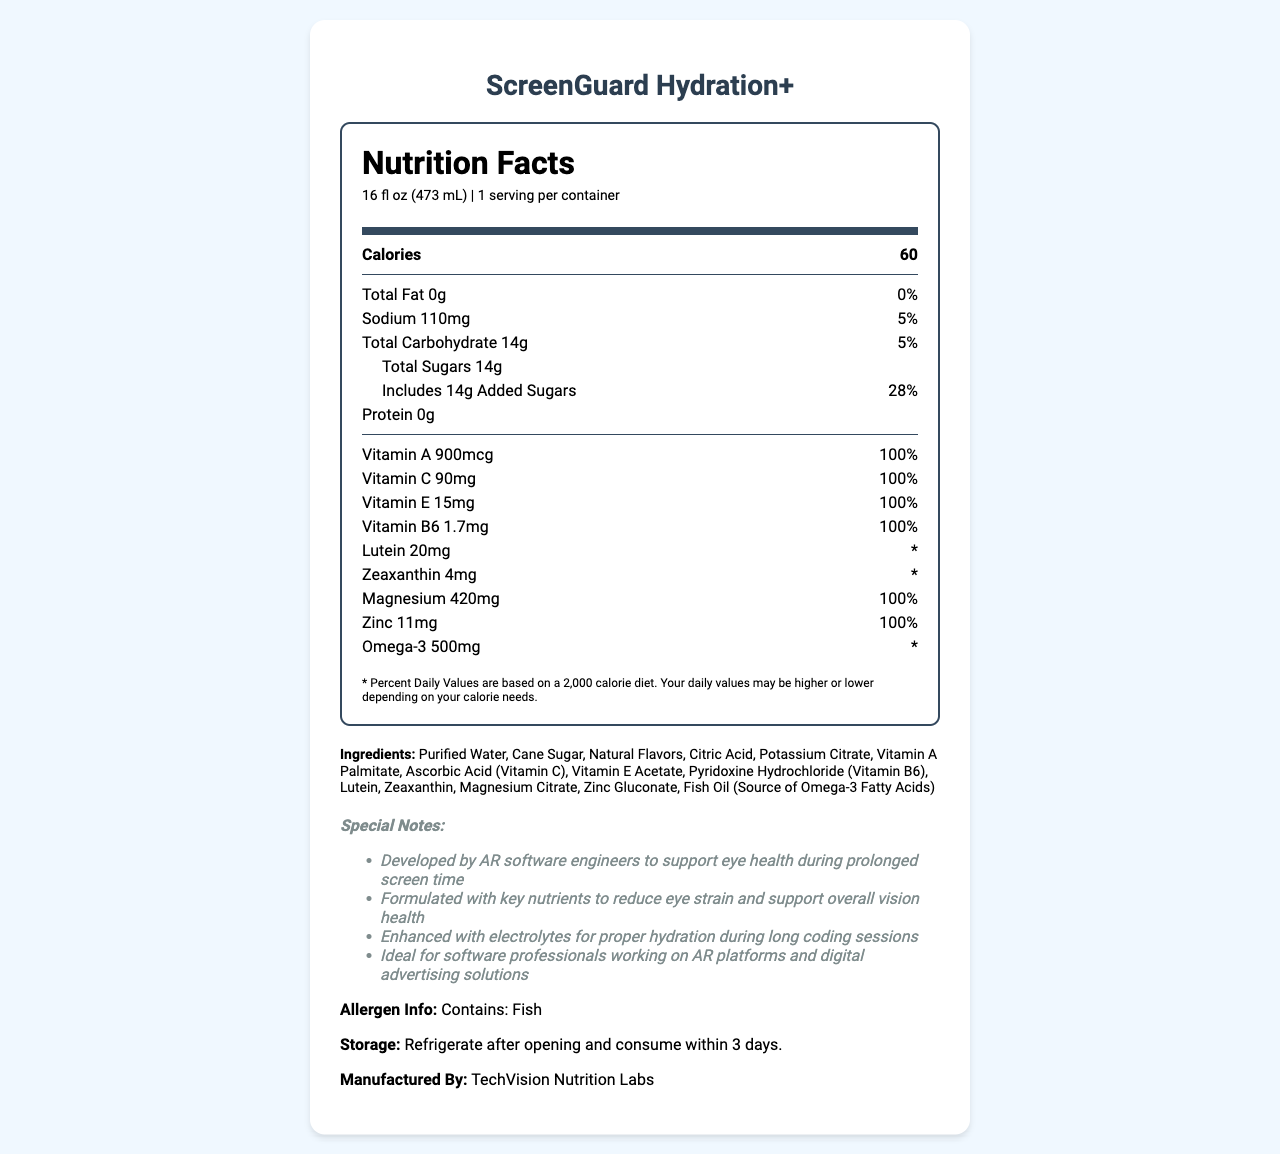how many calories are in one serving of ScreenGuard Hydration+? The document lists the calorie content as "60" under the section with a bolded "Calories" label.
Answer: 60 what is the serving size for this product? The serving size is listed right under the product name at the top of the document.
Answer: 16 fl oz (473 mL) what vitamin is present in the highest daily value percentage? Each of these vitamins and minerals are listed with 100% daily value which is the highest percentage on the label.
Answer: Vitamin A, Vitamin C, Vitamin E, Vitamin B6, Magnesium, Zinc does ScreenGuard Hydration+ contain any protein? The document clearly shows "Protein 0g" indicating there is no protein present in the product.
Answer: No How much sodium is present in each serving? Under the Sodium section, it lists the amount as 110mg.
Answer: 110mg which ingredient is a major allergen in this product? The allergen information states "Contains: Fish."
Answer: Fish How much sugar does this product include, and how much of it is added sugars? The document lists 14g for Total Sugars and then states that this includes 14g Added Sugars.
Answer: 14g total, 14g added sugars What is the percentage of daily value of magnesium in one serving? Listed directly under magnesium in the label, the percentage is 100% of the daily value.
Answer: 100% What is the primary purpose of ScreenGuard Hydration+ according to the special notes? A. Promote overall health B. Support eye health during screen exposure C. Improve digestion The special notes specifically mention it was developed to support eye health during prolonged screen time.
Answer: B. Support eye health during screen exposure Which vitamin is fortified to 90mg in ScreenGuard Hydration+? A. Vitamin A B. Vitamin C C. Vitamin E D. Vitamin B6 The label lists Vitamin C with the amount of 90mg and a daily value of 100%.
Answer: B. Vitamin C Is this product considered fat-free? The document states "Total Fat 0g" which indicates it is fat-free.
Answer: Yes Summarize the nutrition and health benefits of ScreenGuard Hydration+. The summary drawing on the entire document highlights its health benefits in combating eye strain and providing essential nutrients.
Answer: ScreenGuard Hydration+ is a hydration drink designed to support eye health during prolonged screen time. It contains 60 calories per serving, with added vitamins A, C, E, B6, magnesium, zinc, lutein, and zeaxanthin—all contributing 100% of the daily value for most of these nutrients. It's fat-free, contains 14 grams of sugars, and 110mg of sodium. Enhanced with electrolytes, it is ideal for software professionals for better hydration and vision support. How many milligrams of Omega-3 are included in the drink? The nutrition label lists Omega-3 with an amount of 500mg.
Answer: 500mg Can I consume this product if I am allergic to fish? The allergen information clearly states that the drink contains fish, meaning it's not suitable for those with fish allergies.
Answer: No What is the purpose of the footnote marked with an asterisk (*)? The footnote clarifies that percent daily values are based on a 2,000 calorie diet and may vary based on individual calorie needs.
Answer: Explains that daily values are based on a 2,000 calorie diet What company manufactures ScreenGuard Hydration+? The manufacturer's information is listed at the end of the document.
Answer: TechVision Nutrition Labs What percentage of daily value of zinc does this drink provide? The nutrition label states that the drink provides 100% of the daily value of zinc.
Answer: 100% What are the special formulation features mentioned in the document? The special notes explain that the product is developed for eye health during screen exposure, reduces eye strain, and contains electrolytes for hydration.
Answer: Developed to support eye health, reduce eye strain, and contain electrolytes for hydration. How should the product be stored after opening? The storage instructions at the end of the document provide this information.
Answer: Refrigerate after opening and consume within 3 days What are the primary benefits of ScreenGuard Hydration+ for a software engineer? The special notes elaborate that it supports eye health and reduces strain, which are benefits for someone working long hours on screens.
Answer: Supports eye health, reduces eye strain, provides essential hydration during long screen exposure. Is the amount of lutein provided in one serving listed as a percent daily value? The document lists the amount as "20mg" but does not include a percent daily value for lutein.
Answer: No 